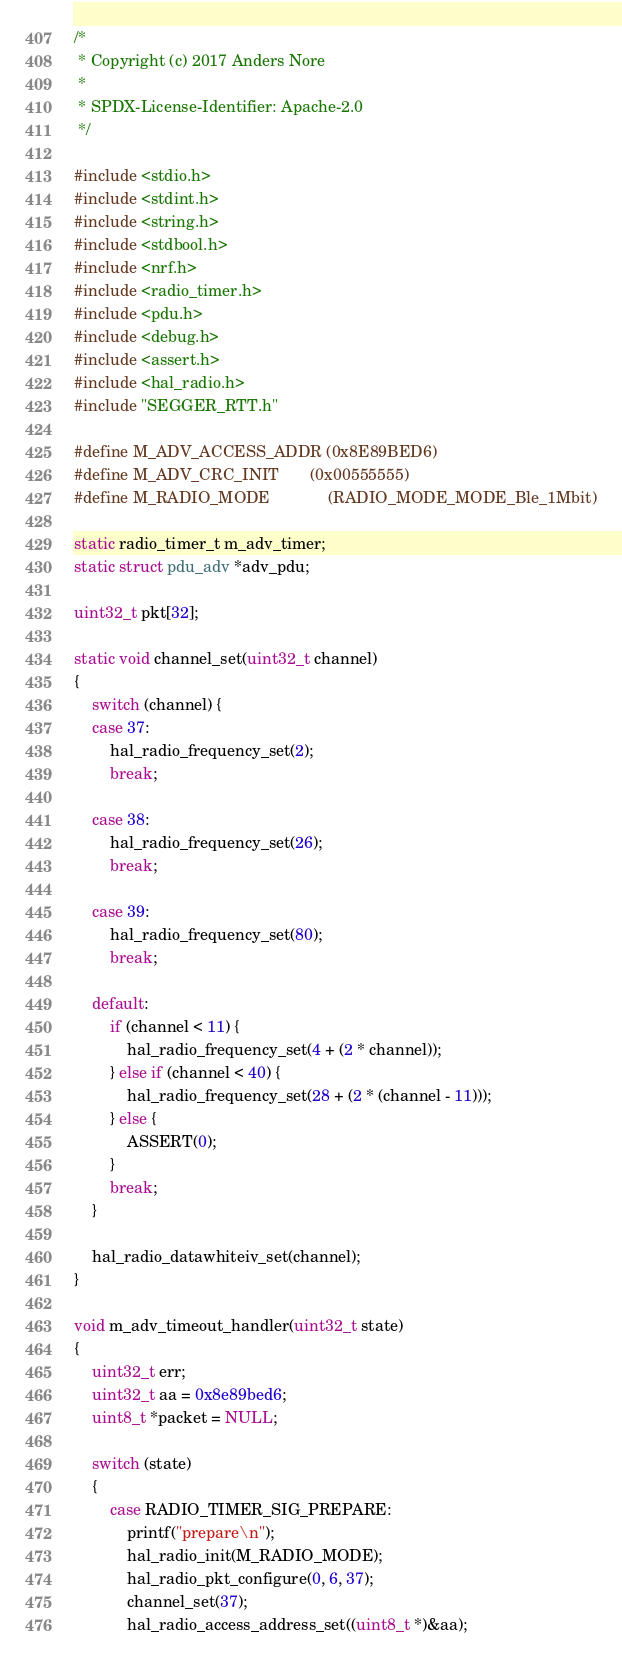<code> <loc_0><loc_0><loc_500><loc_500><_C_>/*
 * Copyright (c) 2017 Anders Nore
 *
 * SPDX-License-Identifier: Apache-2.0
 */

#include <stdio.h>
#include <stdint.h>
#include <string.h>
#include <stdbool.h>
#include <nrf.h>
#include <radio_timer.h>
#include <pdu.h>
#include <debug.h>
#include <assert.h>
#include <hal_radio.h>
#include "SEGGER_RTT.h"

#define M_ADV_ACCESS_ADDR (0x8E89BED6)
#define M_ADV_CRC_INIT 		(0x00555555)
#define M_RADIO_MODE 			(RADIO_MODE_MODE_Ble_1Mbit)

static radio_timer_t m_adv_timer;
static struct pdu_adv *adv_pdu;

uint32_t pkt[32];

static void channel_set(uint32_t channel)
{
	switch (channel) {
	case 37:
		hal_radio_frequency_set(2);
		break;

	case 38:
		hal_radio_frequency_set(26);
		break;

	case 39:
		hal_radio_frequency_set(80);
		break;

	default:
		if (channel < 11) {
			hal_radio_frequency_set(4 + (2 * channel));
		} else if (channel < 40) {
			hal_radio_frequency_set(28 + (2 * (channel - 11)));
		} else {
			ASSERT(0);
		}
		break;
	}

	hal_radio_datawhiteiv_set(channel);
}

void m_adv_timeout_handler(uint32_t state)
{
	uint32_t err;
	uint32_t aa = 0x8e89bed6;
	uint8_t *packet = NULL;

	switch (state)
	{
		case RADIO_TIMER_SIG_PREPARE:
			printf("prepare\n");
			hal_radio_init(M_RADIO_MODE);
			hal_radio_pkt_configure(0, 6, 37);
			channel_set(37);
			hal_radio_access_address_set((uint8_t *)&aa);</code> 